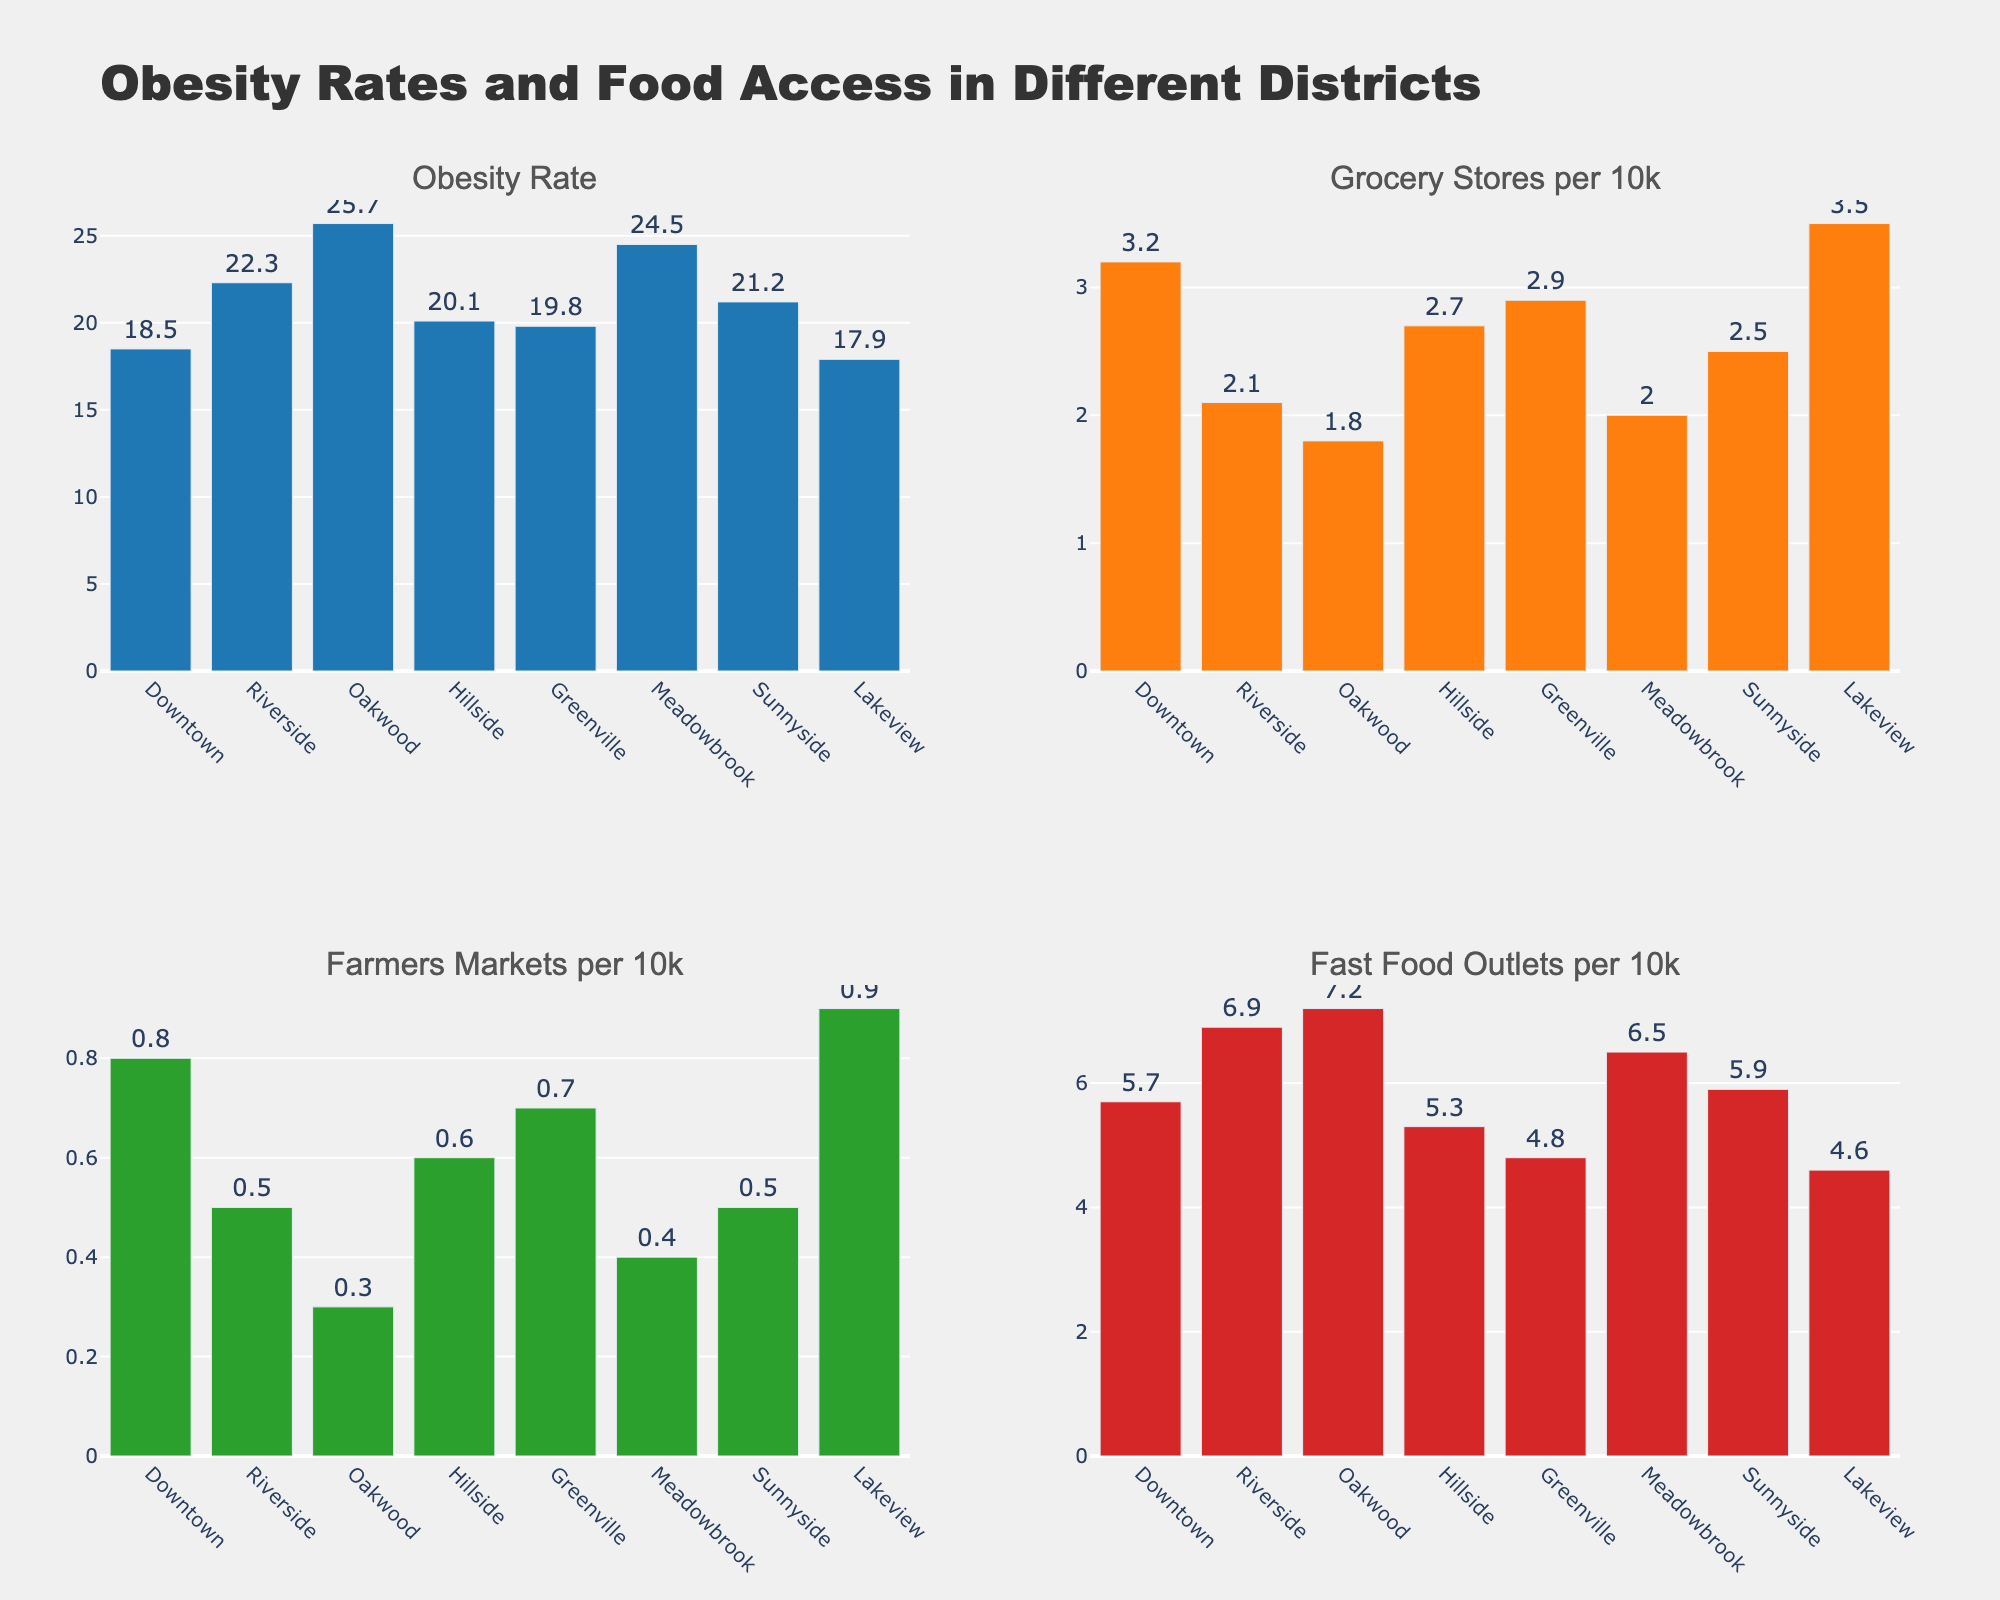What's the district with the highest obesity rate? The figure shows the obesity rates of different districts. The highest bar in the "Obesity Rate" subplot corresponds to Oakwood.
Answer: Oakwood What's the average number of grocery stores per 10k in all districts? The sum of grocery stores per 10k in all districts is 3.2+2.1+1.8+2.7+2.9+2.0+2.5+3.5=20.7. There are 8 districts in total. So, the average is 20.7/8.
Answer: 2.588 Which district has the lowest number of farmers markets per 10k? By observing the "Farmers Markets per 10k" subplot, Oakwood has the shortest bar, indicating the lowest number.
Answer: Oakwood Compare Riverside and Greenville: Which district has fewer fast food outlets per 10k, and by how much? Riverside has 6.9 fast food outlets per 10k, while Greenville has 4.8. Subtracting the two: 6.9 - 4.8 = 2.1. Therefore, Greenville has fewer outlets, and the difference is 2.1.
Answer: Greenville, 2.1 What's the total number of districts with an obesity rate above 20%? The districts with obesity rates above 20% are Riverside, Oakwood, Meadowbrook, and Sunnyside. Counting these districts results in 4.
Answer: 4 Which areas have more than 3 grocery stores per 10k? The "Grocery Stores per 10k" subplot shows Downtown (3.2) and Lakeview (3.5) with more than 3 grocery stores per 10k.
Answer: Downtown, Lakeview Is there any district that has the highest or lowest in more than one category? Oakwood has the highest obesity rate and the lowest number of farmers markets per 10k. No other district achieves this in multiple categories.
Answer: Oakwood Which district has the highest number of fast food outlets per 10k? By examining the "Fast Food Outlets per 10k" subplot, Oakwood has the tallest bar, indicating the highest number.
Answer: Oakwood What is the difference between the obesity rates of Downtown and Lakeview? Downtown has an obesity rate of 18.5, and Lakeview has 17.9. Subtracting the two: 18.5 - 17.9 = 0.6.
Answer: 0.6 